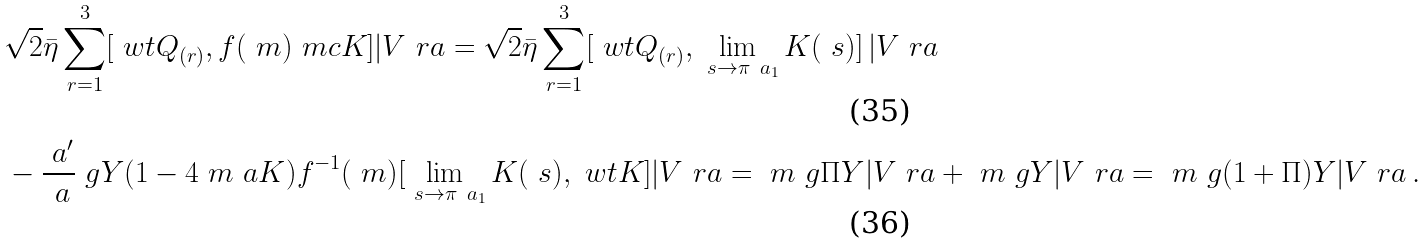<formula> <loc_0><loc_0><loc_500><loc_500>& \sqrt { 2 } \bar { \eta } \sum _ { r = 1 } ^ { 3 } [ \ w t { Q } _ { ( r ) } , f ( \ m ) { \ m c K } ] | V \ r a = \sqrt { 2 } \bar { \eta } \sum _ { r = 1 } ^ { 3 } [ \ w t { Q } _ { ( r ) } , \lim _ { \ s \to \pi \ a _ { 1 } } K ( \ s ) ] \, | V \ r a \\ & - \frac { \ a ^ { \prime } } { \ a } \ g Y ( 1 - 4 \ m \ a K ) f ^ { - 1 } ( \ m ) [ \lim _ { \ s \to \pi \ a _ { 1 } } K ( \ s ) , \ w t { K } ] | V \ r a = \ m \ g \Pi Y | V \ r a + \ m \ g Y | V \ r a = \ m \ g ( 1 + \Pi ) Y | V \ r a \, .</formula> 